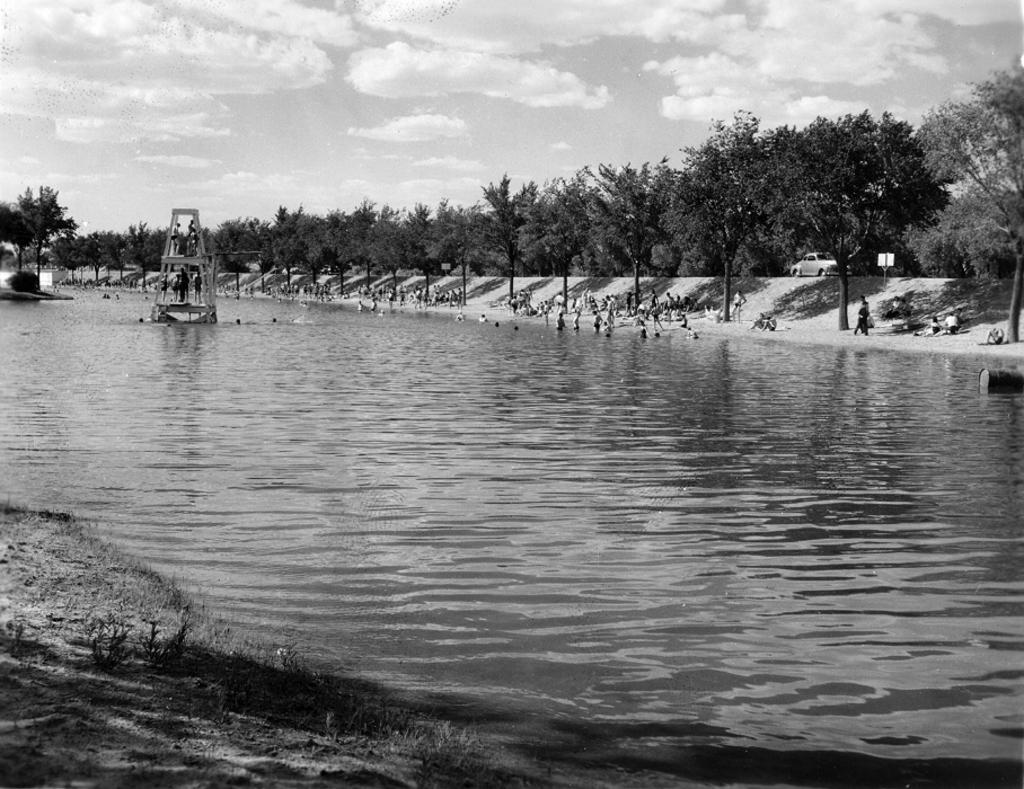What is the primary element present in the image? There is water in the image. What else can be seen in the image besides the water? There are objects, a group of people, a name board, a vehicle, trees, and the sky visible in the image. Where are the people located in relation to the water? The group of people is beside the water. What is the purpose of the name board in the image? The name board provides information or identification about the location or object in the image. What type of vehicle is present in the image? The type of vehicle cannot be determined from the provided facts. Are there any horses on fire in the image? No, there are no horses or fire present in the image. Can you see the moon in the image? No, the sky is visible in the background of the image, but the moon is not mentioned or depicted. 